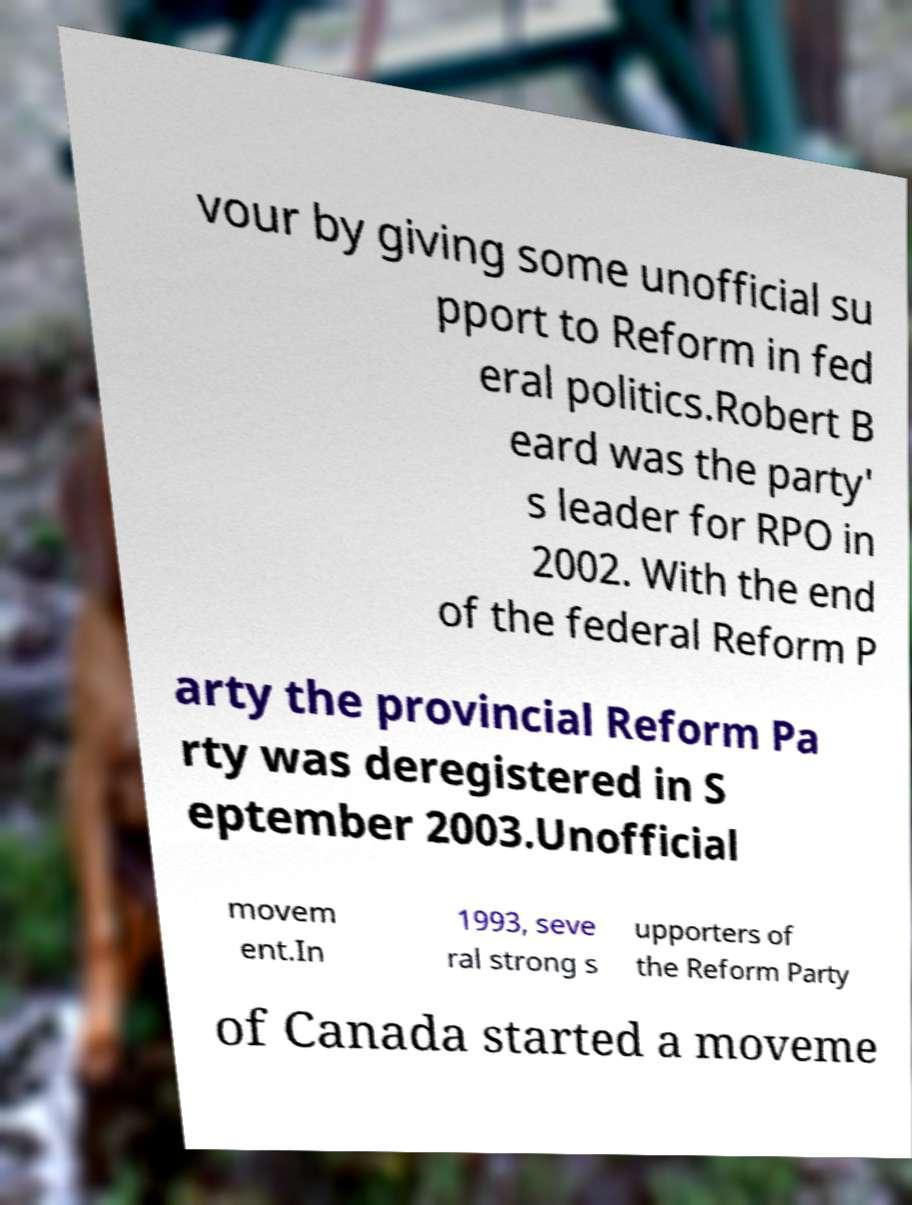Please read and relay the text visible in this image. What does it say? vour by giving some unofficial su pport to Reform in fed eral politics.Robert B eard was the party' s leader for RPO in 2002. With the end of the federal Reform P arty the provincial Reform Pa rty was deregistered in S eptember 2003.Unofficial movem ent.In 1993, seve ral strong s upporters of the Reform Party of Canada started a moveme 